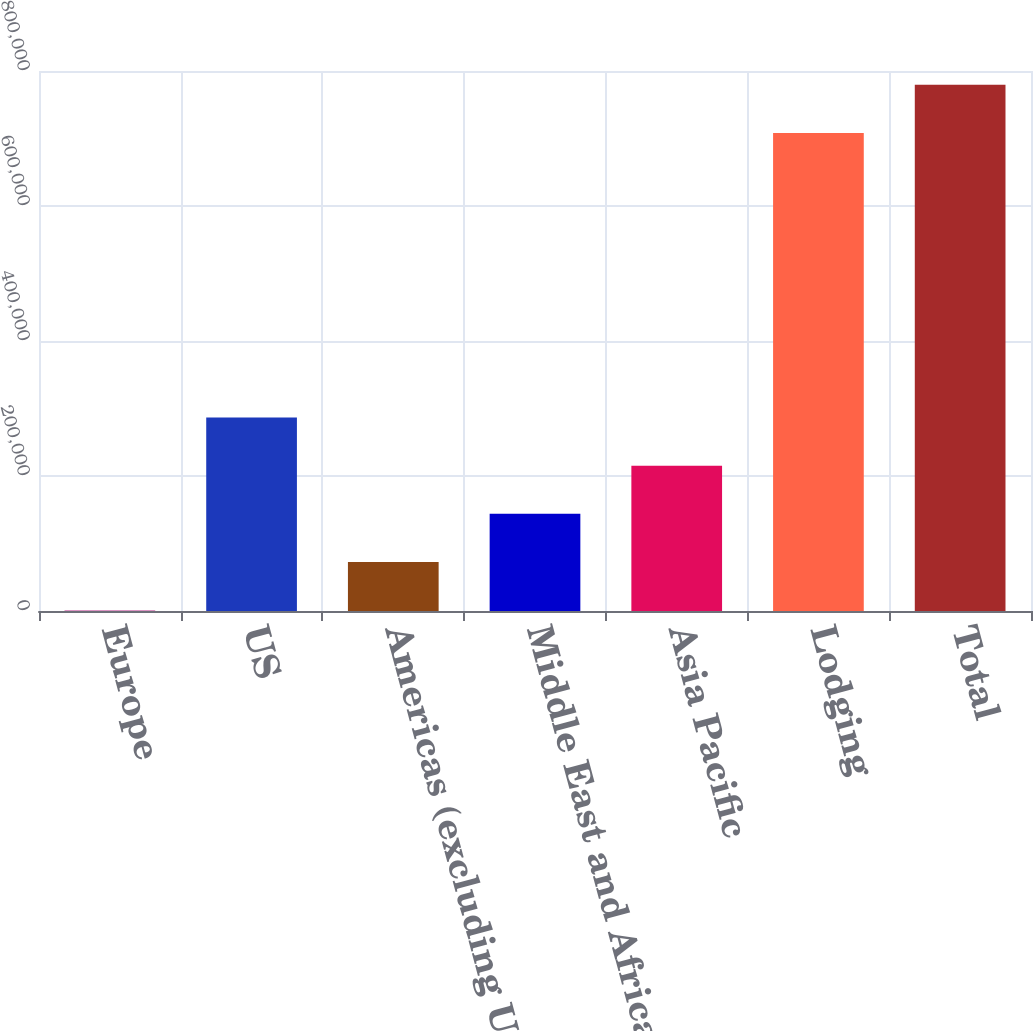<chart> <loc_0><loc_0><loc_500><loc_500><bar_chart><fcel>Europe<fcel>US<fcel>Americas (excluding US)<fcel>Middle East and Africa<fcel>Asia Pacific<fcel>Lodging<fcel>Total<nl><fcel>1152<fcel>286716<fcel>72543<fcel>143934<fcel>215325<fcel>708268<fcel>779659<nl></chart> 